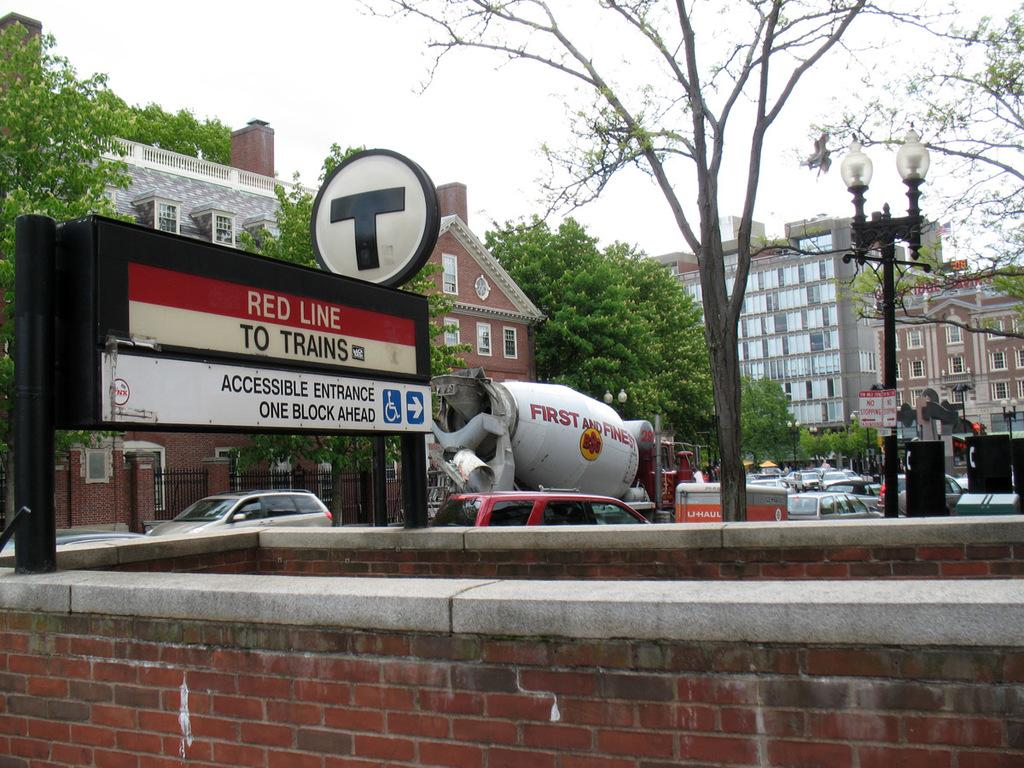What type of structure can be seen in the image? There is a brick wall in the image. What else can be seen in the image besides the brick wall? There are boards, vehicles moving on the road, light poles, buildings, trees, and the sky visible in the background. How many types of structures are present in the image? There are at least two types of structures: a brick wall and buildings. What is the purpose of the light poles in the image? The light poles are likely used for illuminating the area at night or during low light conditions. What type of books can be found in the library depicted in the image? There is no library present in the image, so it is not possible to determine what type of books might be found there. 